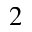<formula> <loc_0><loc_0><loc_500><loc_500>_ { 2 }</formula> 